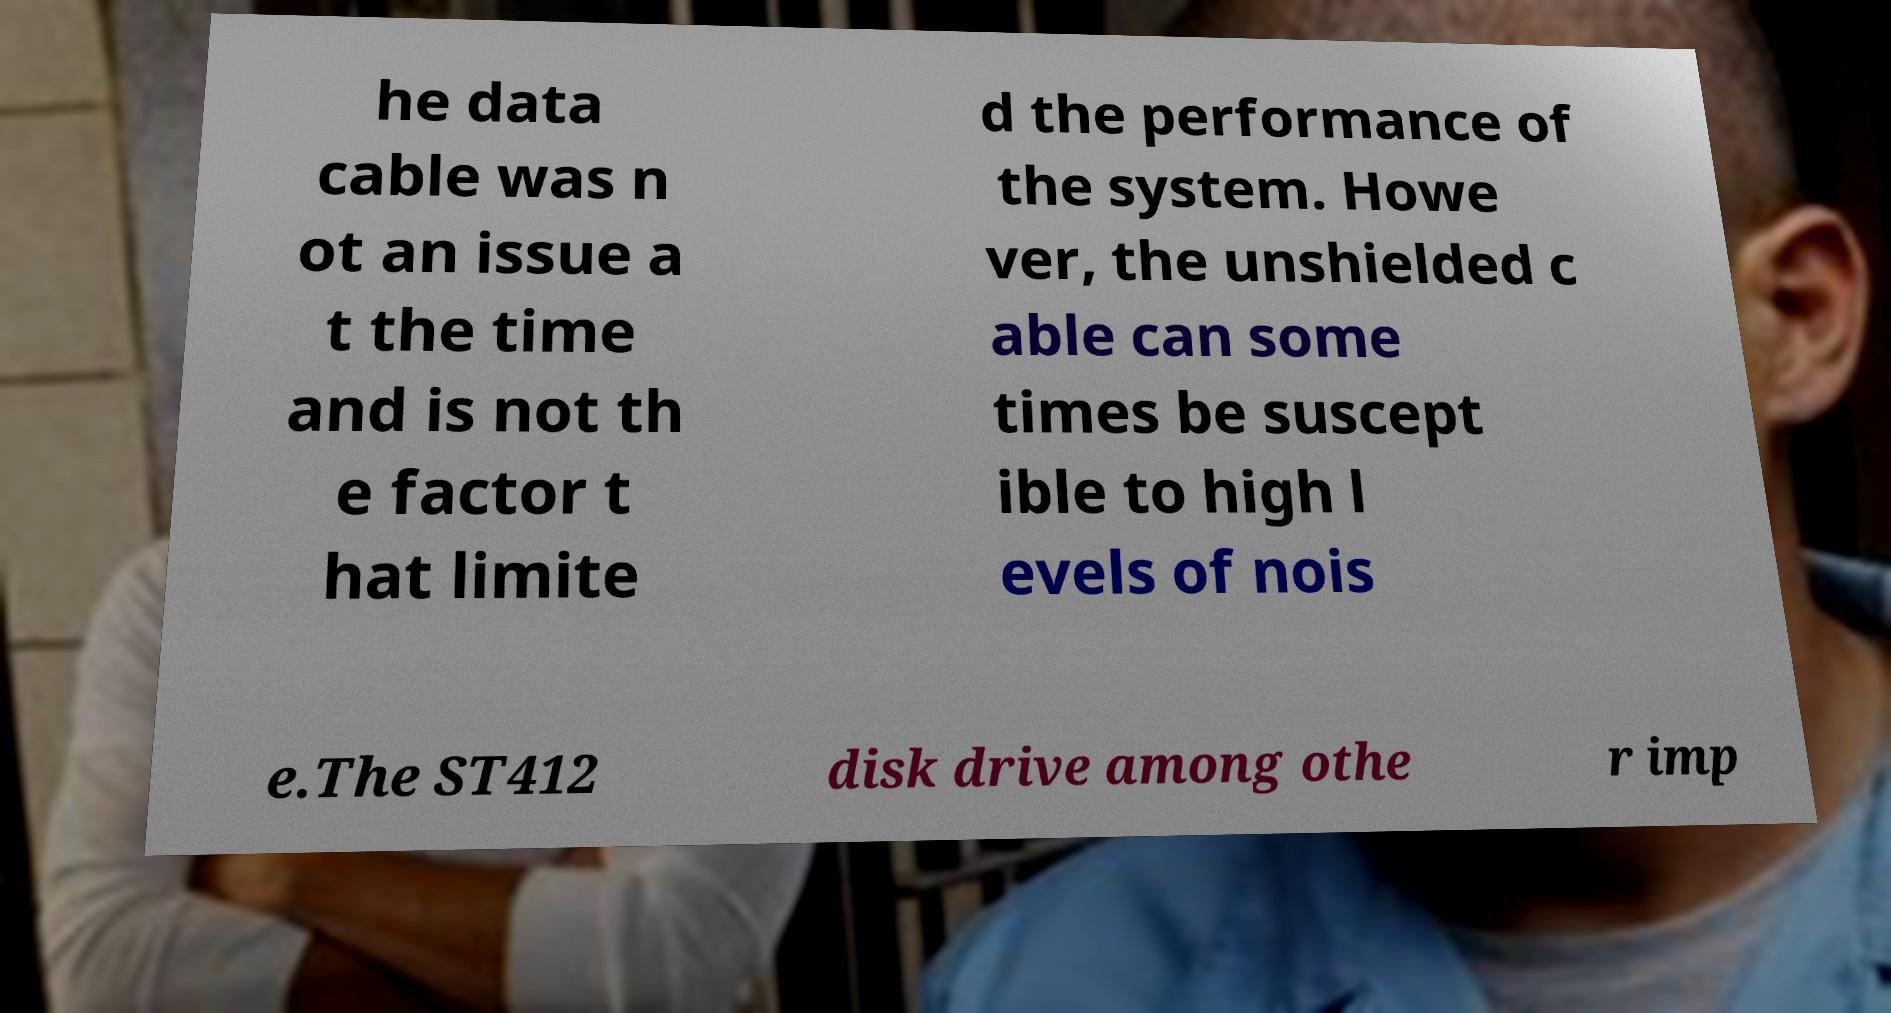Please identify and transcribe the text found in this image. he data cable was n ot an issue a t the time and is not th e factor t hat limite d the performance of the system. Howe ver, the unshielded c able can some times be suscept ible to high l evels of nois e.The ST412 disk drive among othe r imp 